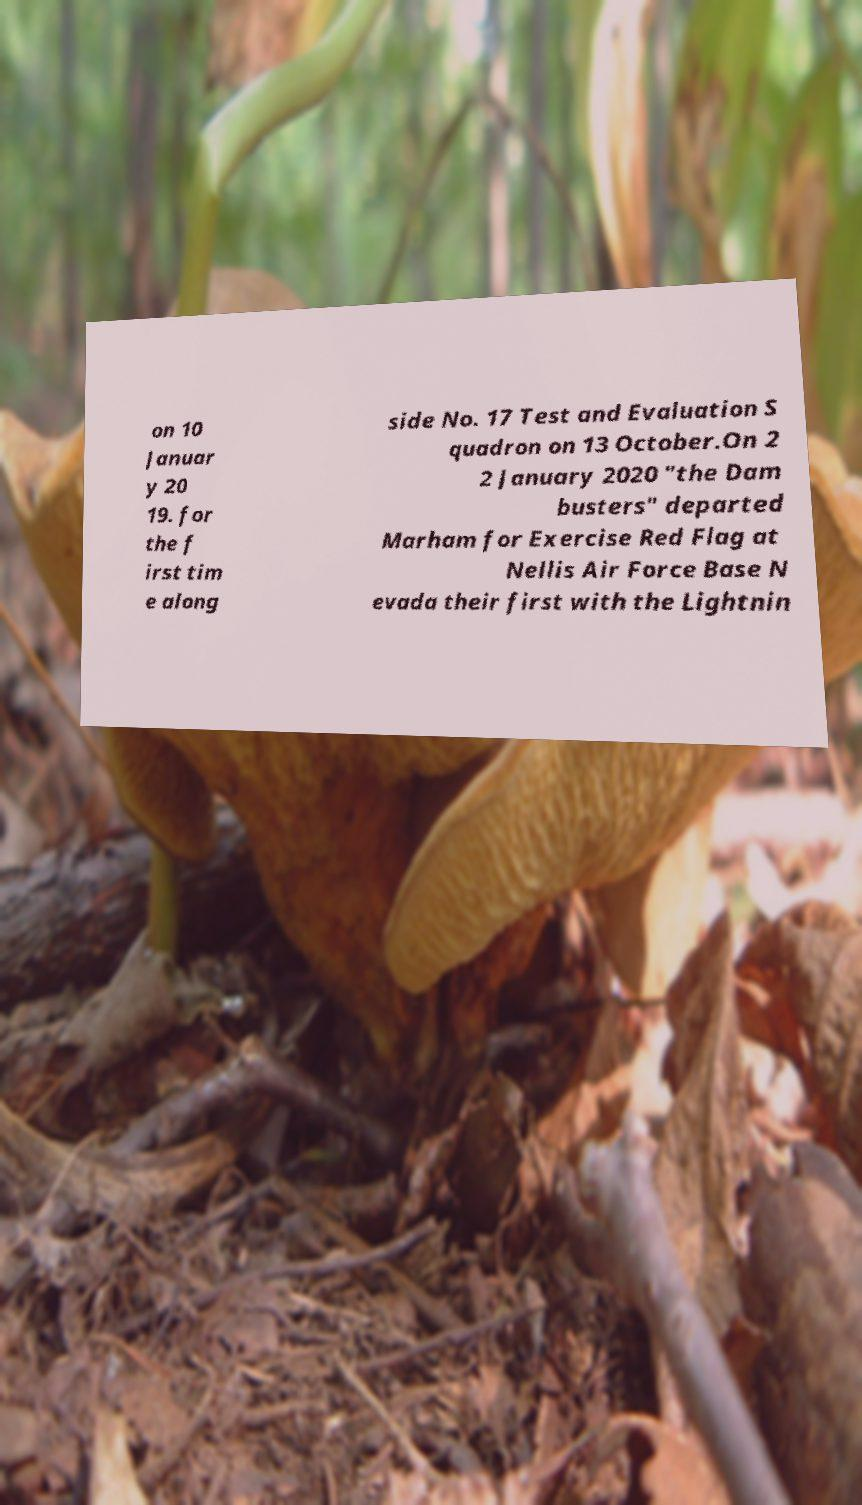For documentation purposes, I need the text within this image transcribed. Could you provide that? on 10 Januar y 20 19. for the f irst tim e along side No. 17 Test and Evaluation S quadron on 13 October.On 2 2 January 2020 "the Dam busters" departed Marham for Exercise Red Flag at Nellis Air Force Base N evada their first with the Lightnin 